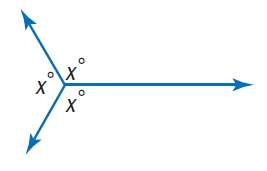Answer the mathemtical geometry problem and directly provide the correct option letter.
Question: Find x.
Choices: A: 60 B: 120 C: 180 D: 240 B 